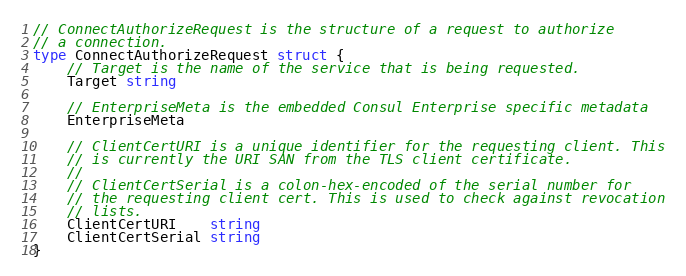Convert code to text. <code><loc_0><loc_0><loc_500><loc_500><_Go_>// ConnectAuthorizeRequest is the structure of a request to authorize
// a connection.
type ConnectAuthorizeRequest struct {
	// Target is the name of the service that is being requested.
	Target string

	// EnterpriseMeta is the embedded Consul Enterprise specific metadata
	EnterpriseMeta

	// ClientCertURI is a unique identifier for the requesting client. This
	// is currently the URI SAN from the TLS client certificate.
	//
	// ClientCertSerial is a colon-hex-encoded of the serial number for
	// the requesting client cert. This is used to check against revocation
	// lists.
	ClientCertURI    string
	ClientCertSerial string
}
</code> 